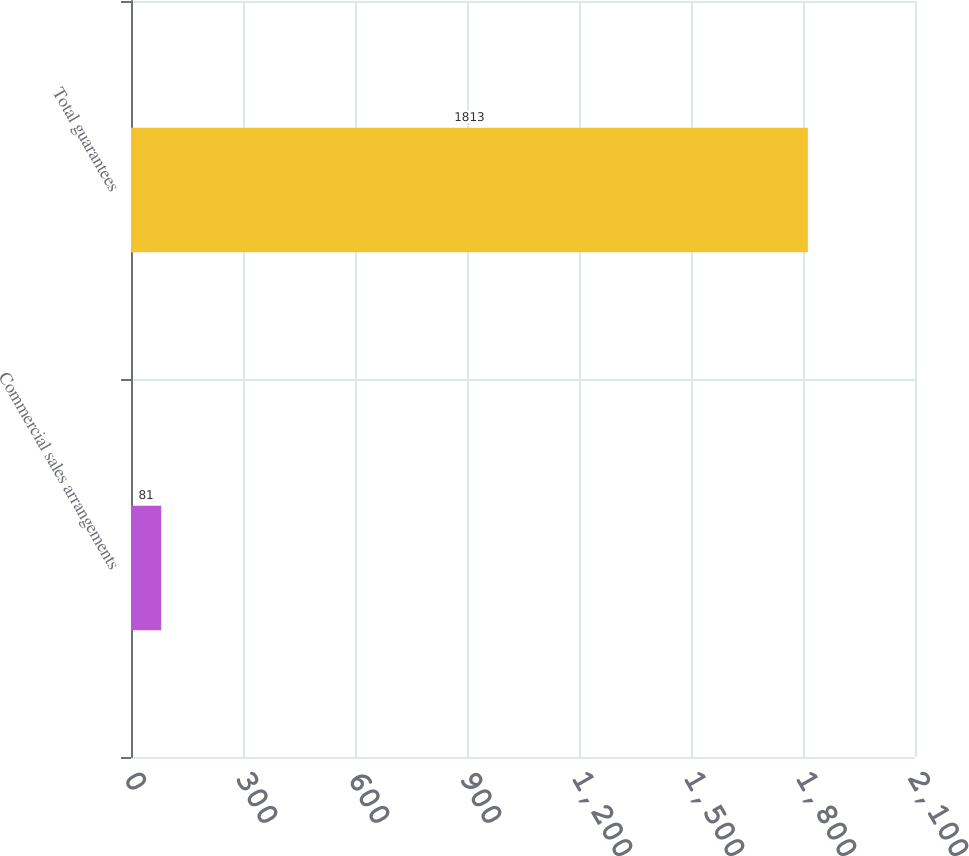Convert chart. <chart><loc_0><loc_0><loc_500><loc_500><bar_chart><fcel>Commercial sales arrangements<fcel>Total guarantees<nl><fcel>81<fcel>1813<nl></chart> 